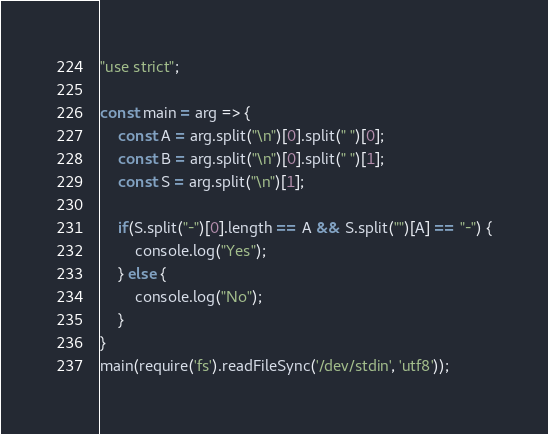<code> <loc_0><loc_0><loc_500><loc_500><_JavaScript_>"use strict";
    
const main = arg => {
    const A = arg.split("\n")[0].split(" ")[0];
    const B = arg.split("\n")[0].split(" ")[1];
    const S = arg.split("\n")[1];
    
    if(S.split("-")[0].length == A && S.split("")[A] == "-") {
        console.log("Yes");
    } else {
        console.log("No");
    }
}
main(require('fs').readFileSync('/dev/stdin', 'utf8'));
</code> 